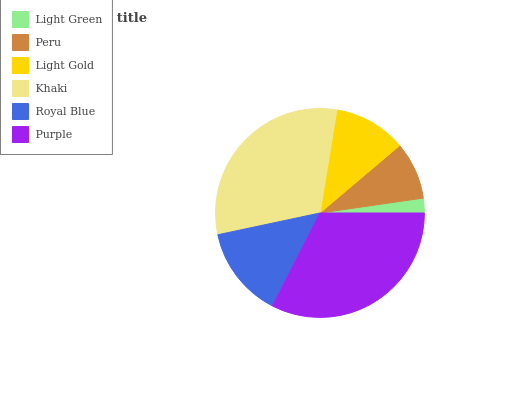Is Light Green the minimum?
Answer yes or no. Yes. Is Purple the maximum?
Answer yes or no. Yes. Is Peru the minimum?
Answer yes or no. No. Is Peru the maximum?
Answer yes or no. No. Is Peru greater than Light Green?
Answer yes or no. Yes. Is Light Green less than Peru?
Answer yes or no. Yes. Is Light Green greater than Peru?
Answer yes or no. No. Is Peru less than Light Green?
Answer yes or no. No. Is Royal Blue the high median?
Answer yes or no. Yes. Is Light Gold the low median?
Answer yes or no. Yes. Is Light Gold the high median?
Answer yes or no. No. Is Peru the low median?
Answer yes or no. No. 